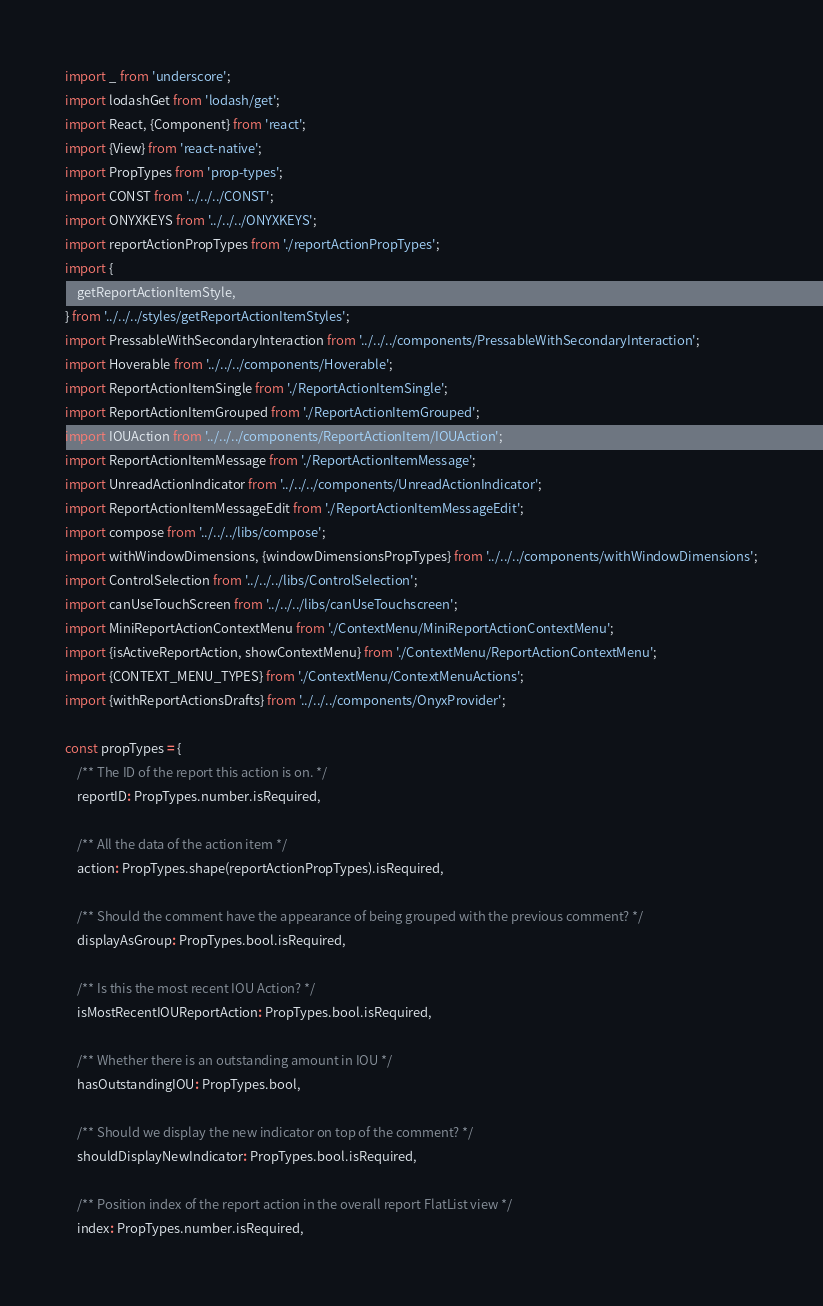Convert code to text. <code><loc_0><loc_0><loc_500><loc_500><_JavaScript_>import _ from 'underscore';
import lodashGet from 'lodash/get';
import React, {Component} from 'react';
import {View} from 'react-native';
import PropTypes from 'prop-types';
import CONST from '../../../CONST';
import ONYXKEYS from '../../../ONYXKEYS';
import reportActionPropTypes from './reportActionPropTypes';
import {
    getReportActionItemStyle,
} from '../../../styles/getReportActionItemStyles';
import PressableWithSecondaryInteraction from '../../../components/PressableWithSecondaryInteraction';
import Hoverable from '../../../components/Hoverable';
import ReportActionItemSingle from './ReportActionItemSingle';
import ReportActionItemGrouped from './ReportActionItemGrouped';
import IOUAction from '../../../components/ReportActionItem/IOUAction';
import ReportActionItemMessage from './ReportActionItemMessage';
import UnreadActionIndicator from '../../../components/UnreadActionIndicator';
import ReportActionItemMessageEdit from './ReportActionItemMessageEdit';
import compose from '../../../libs/compose';
import withWindowDimensions, {windowDimensionsPropTypes} from '../../../components/withWindowDimensions';
import ControlSelection from '../../../libs/ControlSelection';
import canUseTouchScreen from '../../../libs/canUseTouchscreen';
import MiniReportActionContextMenu from './ContextMenu/MiniReportActionContextMenu';
import {isActiveReportAction, showContextMenu} from './ContextMenu/ReportActionContextMenu';
import {CONTEXT_MENU_TYPES} from './ContextMenu/ContextMenuActions';
import {withReportActionsDrafts} from '../../../components/OnyxProvider';

const propTypes = {
    /** The ID of the report this action is on. */
    reportID: PropTypes.number.isRequired,

    /** All the data of the action item */
    action: PropTypes.shape(reportActionPropTypes).isRequired,

    /** Should the comment have the appearance of being grouped with the previous comment? */
    displayAsGroup: PropTypes.bool.isRequired,

    /** Is this the most recent IOU Action? */
    isMostRecentIOUReportAction: PropTypes.bool.isRequired,

    /** Whether there is an outstanding amount in IOU */
    hasOutstandingIOU: PropTypes.bool,

    /** Should we display the new indicator on top of the comment? */
    shouldDisplayNewIndicator: PropTypes.bool.isRequired,

    /** Position index of the report action in the overall report FlatList view */
    index: PropTypes.number.isRequired,
</code> 